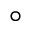Convert formula to latex. <formula><loc_0><loc_0><loc_500><loc_500>^ { \circ }</formula> 